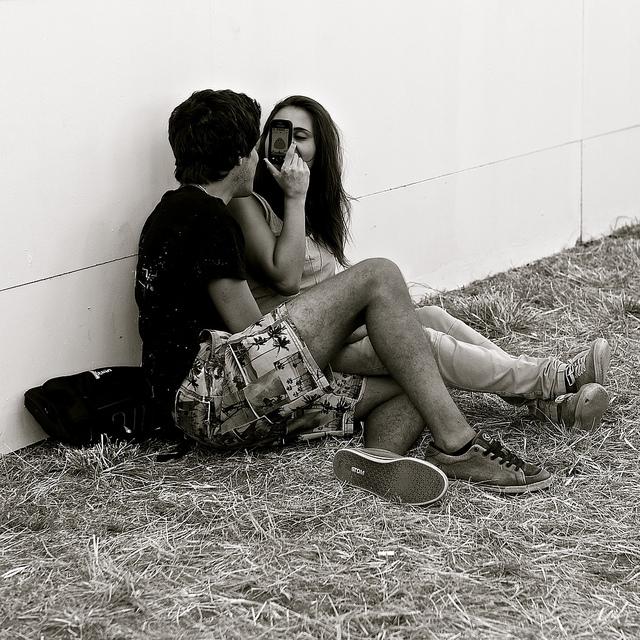How many people are shown?
Short answer required. 2. Is this woman using an iPhone?
Give a very brief answer. No. Do they live here?
Keep it brief. No. 